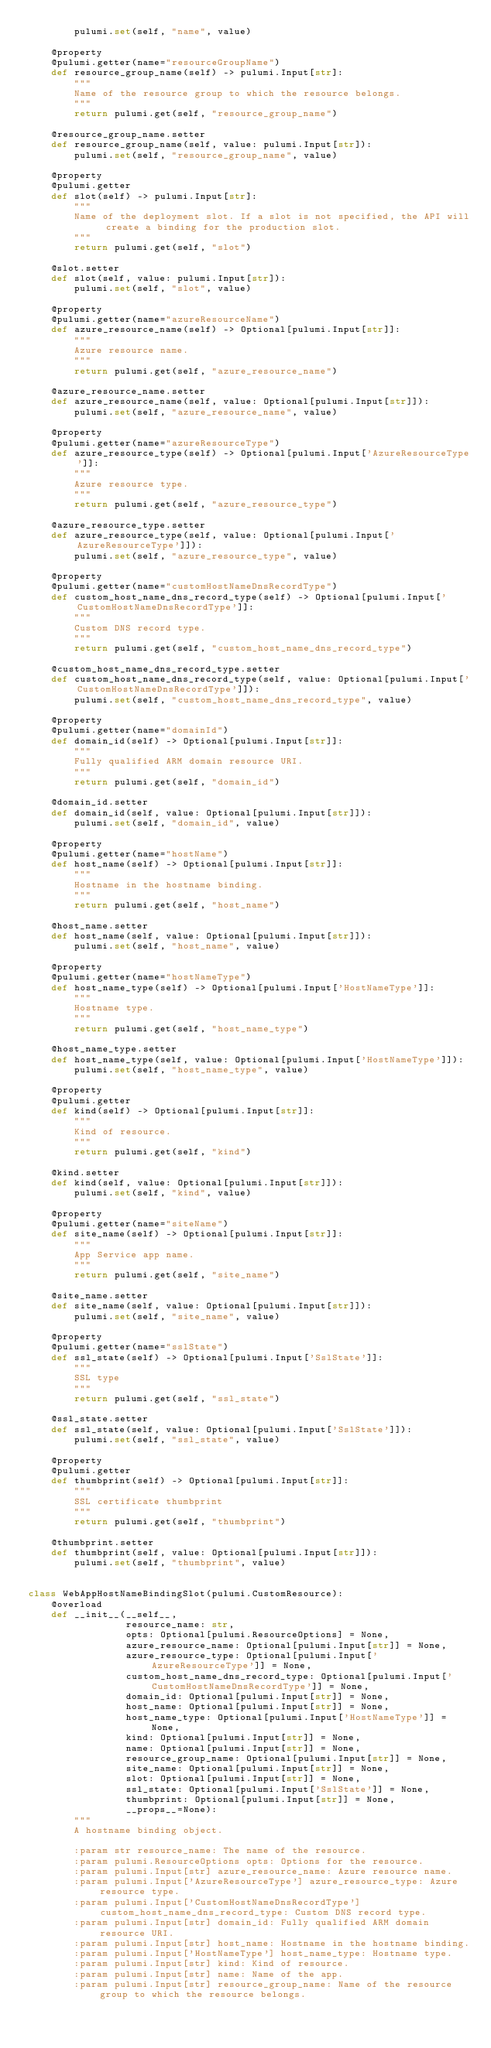Convert code to text. <code><loc_0><loc_0><loc_500><loc_500><_Python_>        pulumi.set(self, "name", value)

    @property
    @pulumi.getter(name="resourceGroupName")
    def resource_group_name(self) -> pulumi.Input[str]:
        """
        Name of the resource group to which the resource belongs.
        """
        return pulumi.get(self, "resource_group_name")

    @resource_group_name.setter
    def resource_group_name(self, value: pulumi.Input[str]):
        pulumi.set(self, "resource_group_name", value)

    @property
    @pulumi.getter
    def slot(self) -> pulumi.Input[str]:
        """
        Name of the deployment slot. If a slot is not specified, the API will create a binding for the production slot.
        """
        return pulumi.get(self, "slot")

    @slot.setter
    def slot(self, value: pulumi.Input[str]):
        pulumi.set(self, "slot", value)

    @property
    @pulumi.getter(name="azureResourceName")
    def azure_resource_name(self) -> Optional[pulumi.Input[str]]:
        """
        Azure resource name.
        """
        return pulumi.get(self, "azure_resource_name")

    @azure_resource_name.setter
    def azure_resource_name(self, value: Optional[pulumi.Input[str]]):
        pulumi.set(self, "azure_resource_name", value)

    @property
    @pulumi.getter(name="azureResourceType")
    def azure_resource_type(self) -> Optional[pulumi.Input['AzureResourceType']]:
        """
        Azure resource type.
        """
        return pulumi.get(self, "azure_resource_type")

    @azure_resource_type.setter
    def azure_resource_type(self, value: Optional[pulumi.Input['AzureResourceType']]):
        pulumi.set(self, "azure_resource_type", value)

    @property
    @pulumi.getter(name="customHostNameDnsRecordType")
    def custom_host_name_dns_record_type(self) -> Optional[pulumi.Input['CustomHostNameDnsRecordType']]:
        """
        Custom DNS record type.
        """
        return pulumi.get(self, "custom_host_name_dns_record_type")

    @custom_host_name_dns_record_type.setter
    def custom_host_name_dns_record_type(self, value: Optional[pulumi.Input['CustomHostNameDnsRecordType']]):
        pulumi.set(self, "custom_host_name_dns_record_type", value)

    @property
    @pulumi.getter(name="domainId")
    def domain_id(self) -> Optional[pulumi.Input[str]]:
        """
        Fully qualified ARM domain resource URI.
        """
        return pulumi.get(self, "domain_id")

    @domain_id.setter
    def domain_id(self, value: Optional[pulumi.Input[str]]):
        pulumi.set(self, "domain_id", value)

    @property
    @pulumi.getter(name="hostName")
    def host_name(self) -> Optional[pulumi.Input[str]]:
        """
        Hostname in the hostname binding.
        """
        return pulumi.get(self, "host_name")

    @host_name.setter
    def host_name(self, value: Optional[pulumi.Input[str]]):
        pulumi.set(self, "host_name", value)

    @property
    @pulumi.getter(name="hostNameType")
    def host_name_type(self) -> Optional[pulumi.Input['HostNameType']]:
        """
        Hostname type.
        """
        return pulumi.get(self, "host_name_type")

    @host_name_type.setter
    def host_name_type(self, value: Optional[pulumi.Input['HostNameType']]):
        pulumi.set(self, "host_name_type", value)

    @property
    @pulumi.getter
    def kind(self) -> Optional[pulumi.Input[str]]:
        """
        Kind of resource.
        """
        return pulumi.get(self, "kind")

    @kind.setter
    def kind(self, value: Optional[pulumi.Input[str]]):
        pulumi.set(self, "kind", value)

    @property
    @pulumi.getter(name="siteName")
    def site_name(self) -> Optional[pulumi.Input[str]]:
        """
        App Service app name.
        """
        return pulumi.get(self, "site_name")

    @site_name.setter
    def site_name(self, value: Optional[pulumi.Input[str]]):
        pulumi.set(self, "site_name", value)

    @property
    @pulumi.getter(name="sslState")
    def ssl_state(self) -> Optional[pulumi.Input['SslState']]:
        """
        SSL type
        """
        return pulumi.get(self, "ssl_state")

    @ssl_state.setter
    def ssl_state(self, value: Optional[pulumi.Input['SslState']]):
        pulumi.set(self, "ssl_state", value)

    @property
    @pulumi.getter
    def thumbprint(self) -> Optional[pulumi.Input[str]]:
        """
        SSL certificate thumbprint
        """
        return pulumi.get(self, "thumbprint")

    @thumbprint.setter
    def thumbprint(self, value: Optional[pulumi.Input[str]]):
        pulumi.set(self, "thumbprint", value)


class WebAppHostNameBindingSlot(pulumi.CustomResource):
    @overload
    def __init__(__self__,
                 resource_name: str,
                 opts: Optional[pulumi.ResourceOptions] = None,
                 azure_resource_name: Optional[pulumi.Input[str]] = None,
                 azure_resource_type: Optional[pulumi.Input['AzureResourceType']] = None,
                 custom_host_name_dns_record_type: Optional[pulumi.Input['CustomHostNameDnsRecordType']] = None,
                 domain_id: Optional[pulumi.Input[str]] = None,
                 host_name: Optional[pulumi.Input[str]] = None,
                 host_name_type: Optional[pulumi.Input['HostNameType']] = None,
                 kind: Optional[pulumi.Input[str]] = None,
                 name: Optional[pulumi.Input[str]] = None,
                 resource_group_name: Optional[pulumi.Input[str]] = None,
                 site_name: Optional[pulumi.Input[str]] = None,
                 slot: Optional[pulumi.Input[str]] = None,
                 ssl_state: Optional[pulumi.Input['SslState']] = None,
                 thumbprint: Optional[pulumi.Input[str]] = None,
                 __props__=None):
        """
        A hostname binding object.

        :param str resource_name: The name of the resource.
        :param pulumi.ResourceOptions opts: Options for the resource.
        :param pulumi.Input[str] azure_resource_name: Azure resource name.
        :param pulumi.Input['AzureResourceType'] azure_resource_type: Azure resource type.
        :param pulumi.Input['CustomHostNameDnsRecordType'] custom_host_name_dns_record_type: Custom DNS record type.
        :param pulumi.Input[str] domain_id: Fully qualified ARM domain resource URI.
        :param pulumi.Input[str] host_name: Hostname in the hostname binding.
        :param pulumi.Input['HostNameType'] host_name_type: Hostname type.
        :param pulumi.Input[str] kind: Kind of resource.
        :param pulumi.Input[str] name: Name of the app.
        :param pulumi.Input[str] resource_group_name: Name of the resource group to which the resource belongs.</code> 